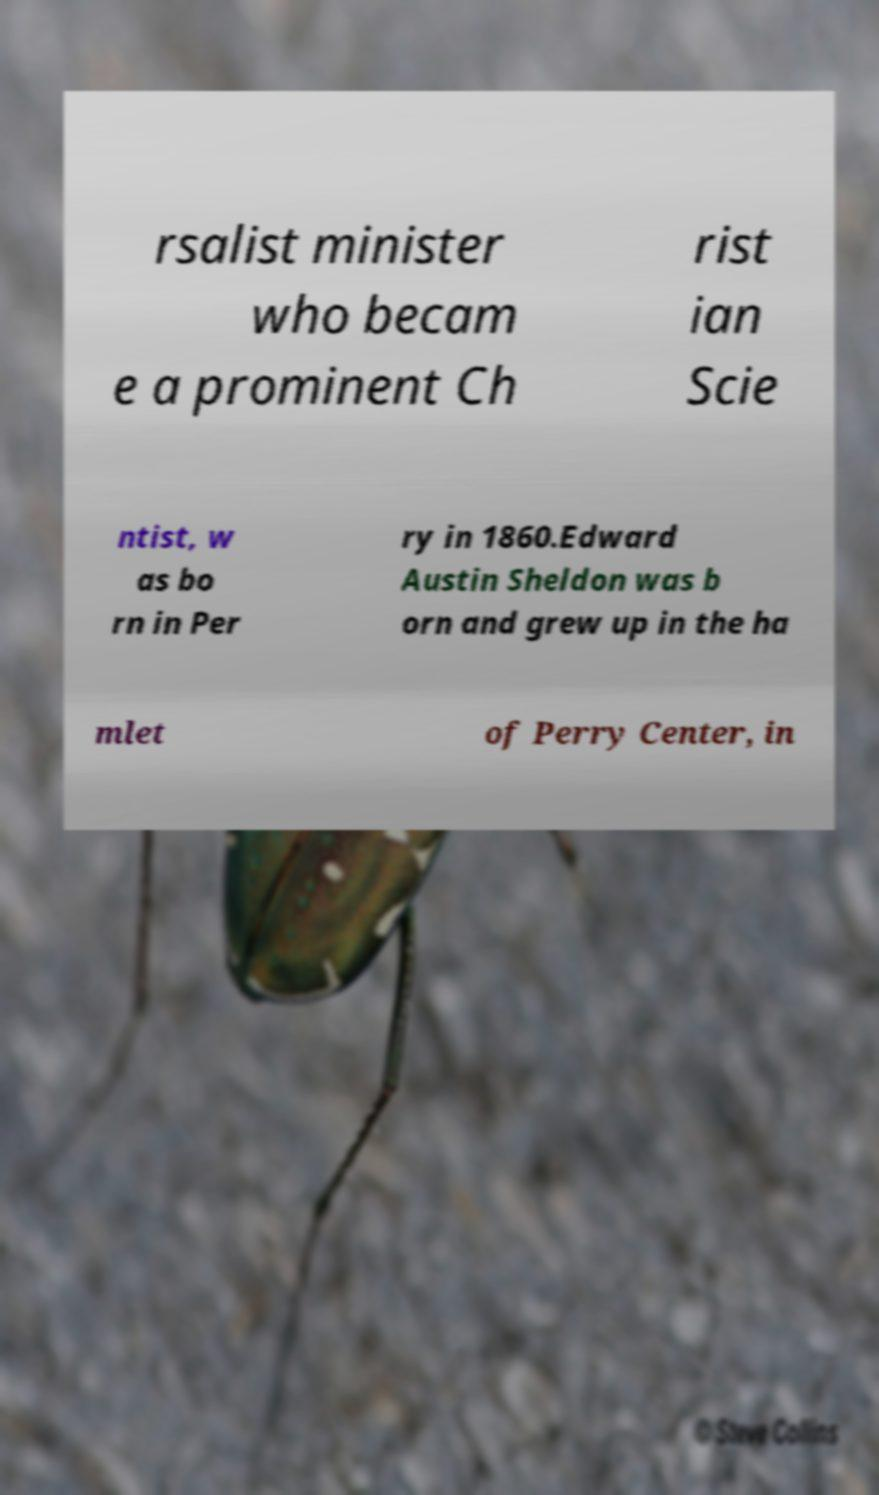Could you assist in decoding the text presented in this image and type it out clearly? rsalist minister who becam e a prominent Ch rist ian Scie ntist, w as bo rn in Per ry in 1860.Edward Austin Sheldon was b orn and grew up in the ha mlet of Perry Center, in 